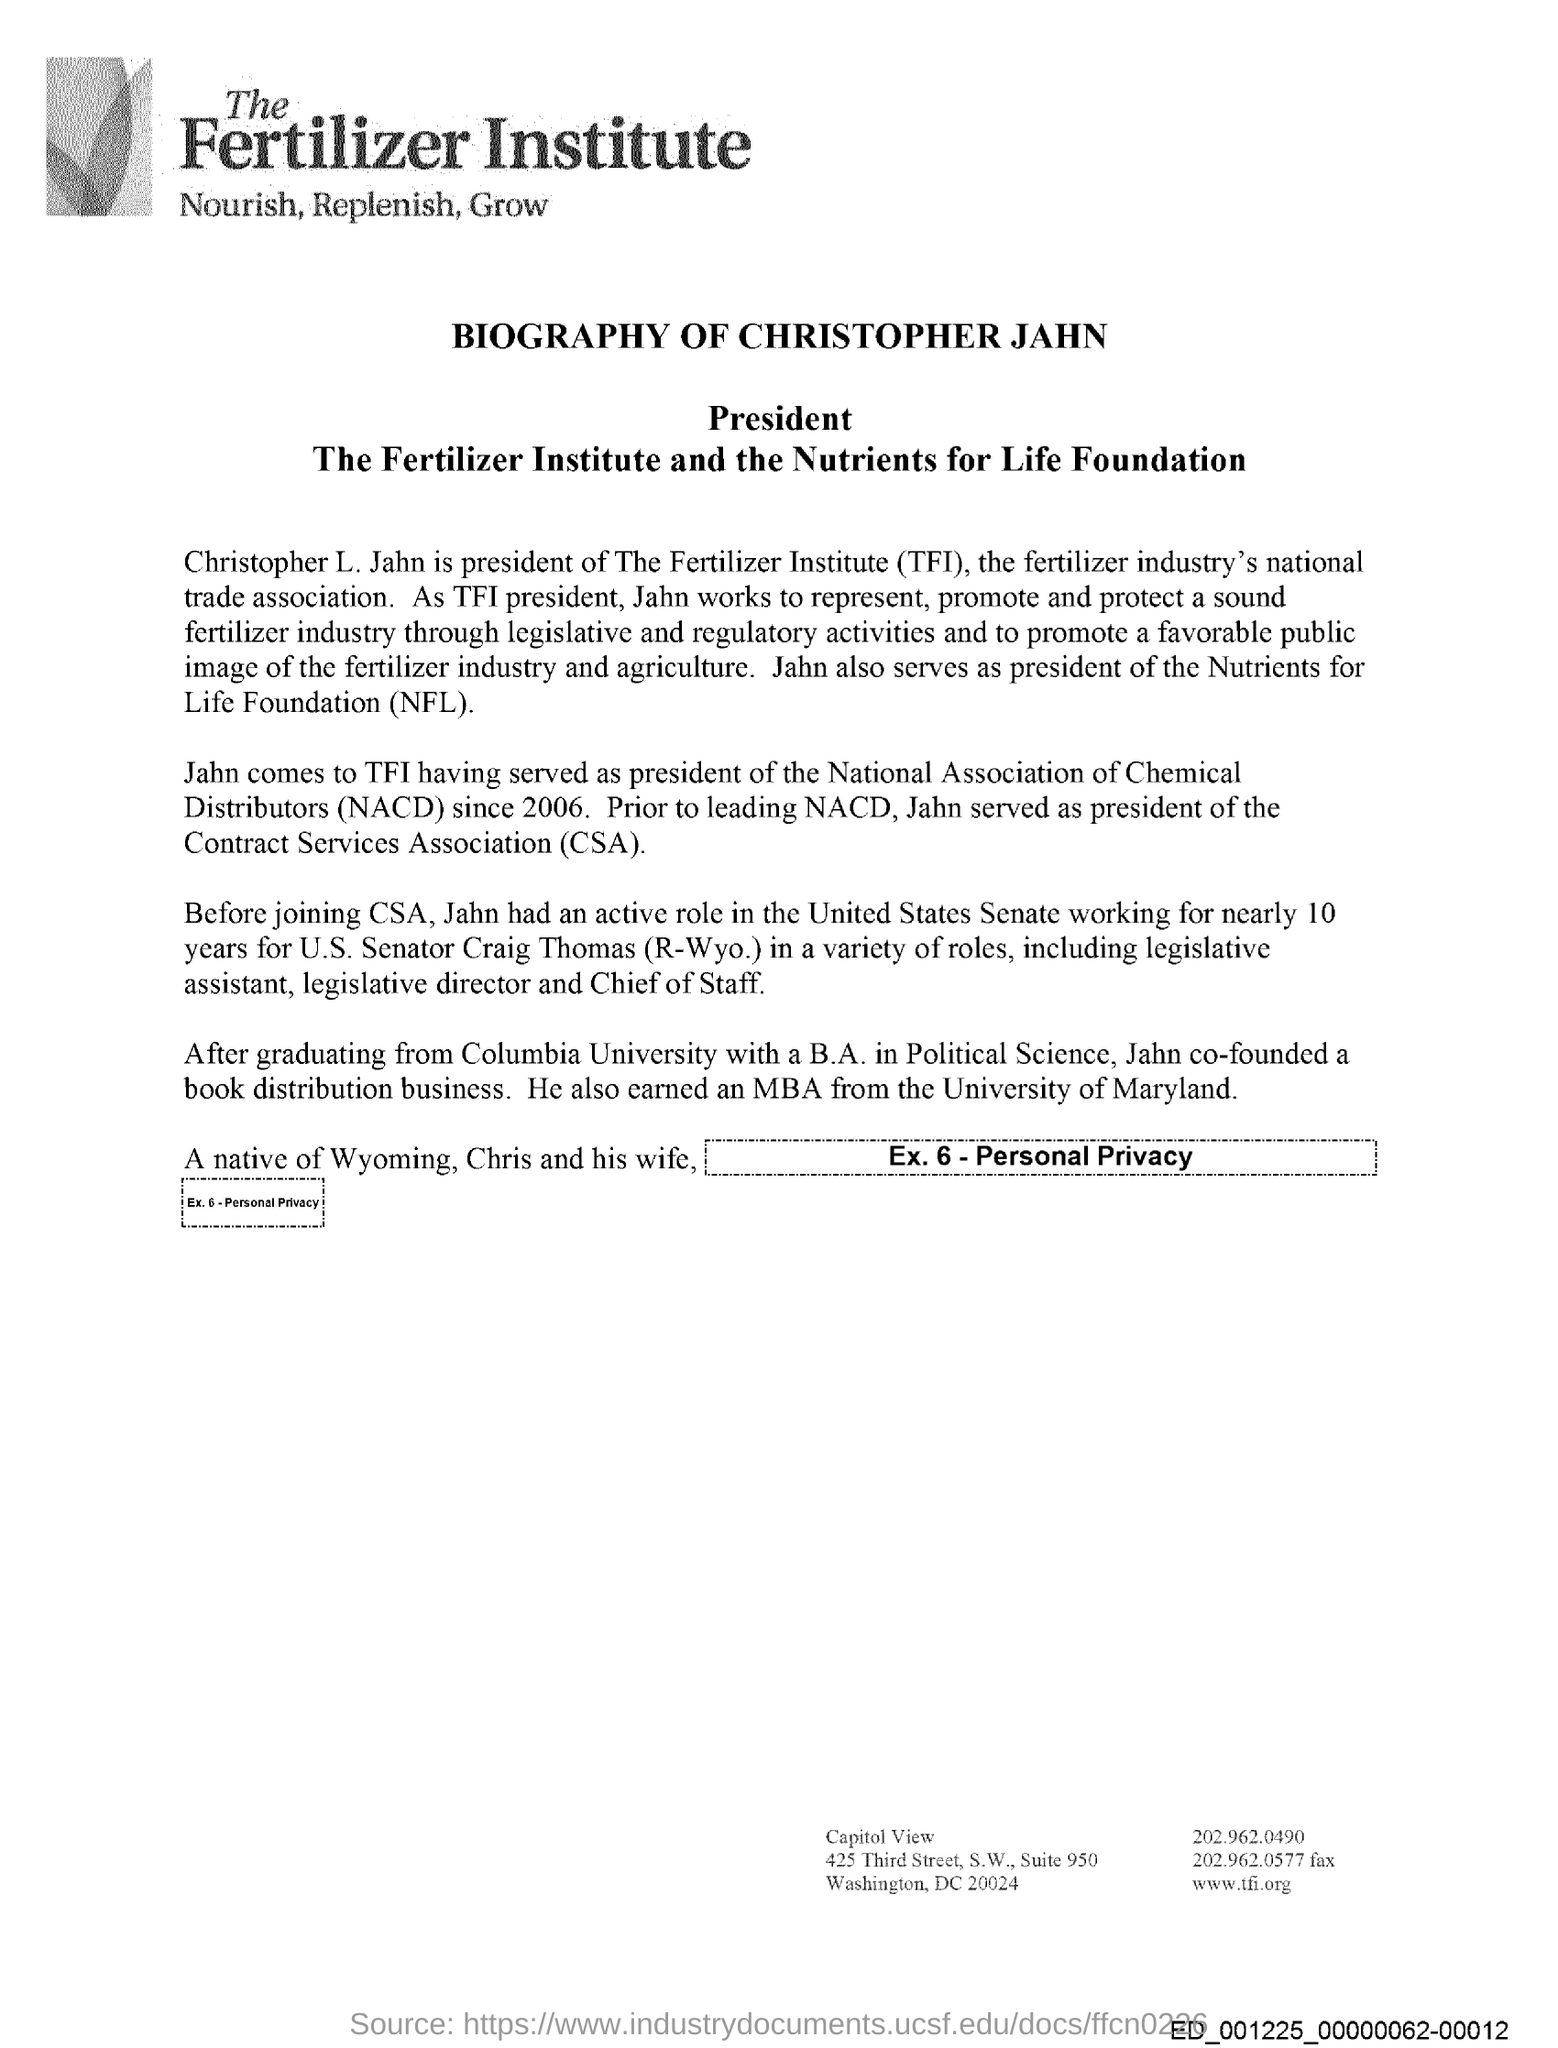Identify some key points in this picture. The Fertilizer Institute, commonly abbreviated as TFI, is a well-known organization that focuses on promoting the use of fertilizers in agriculture. Christopher Jahn worked for U.S. Senator Craig Thomas for 10 years. The full form of CSA is Contract Services Association. Christopher Jahn's biography is this. 